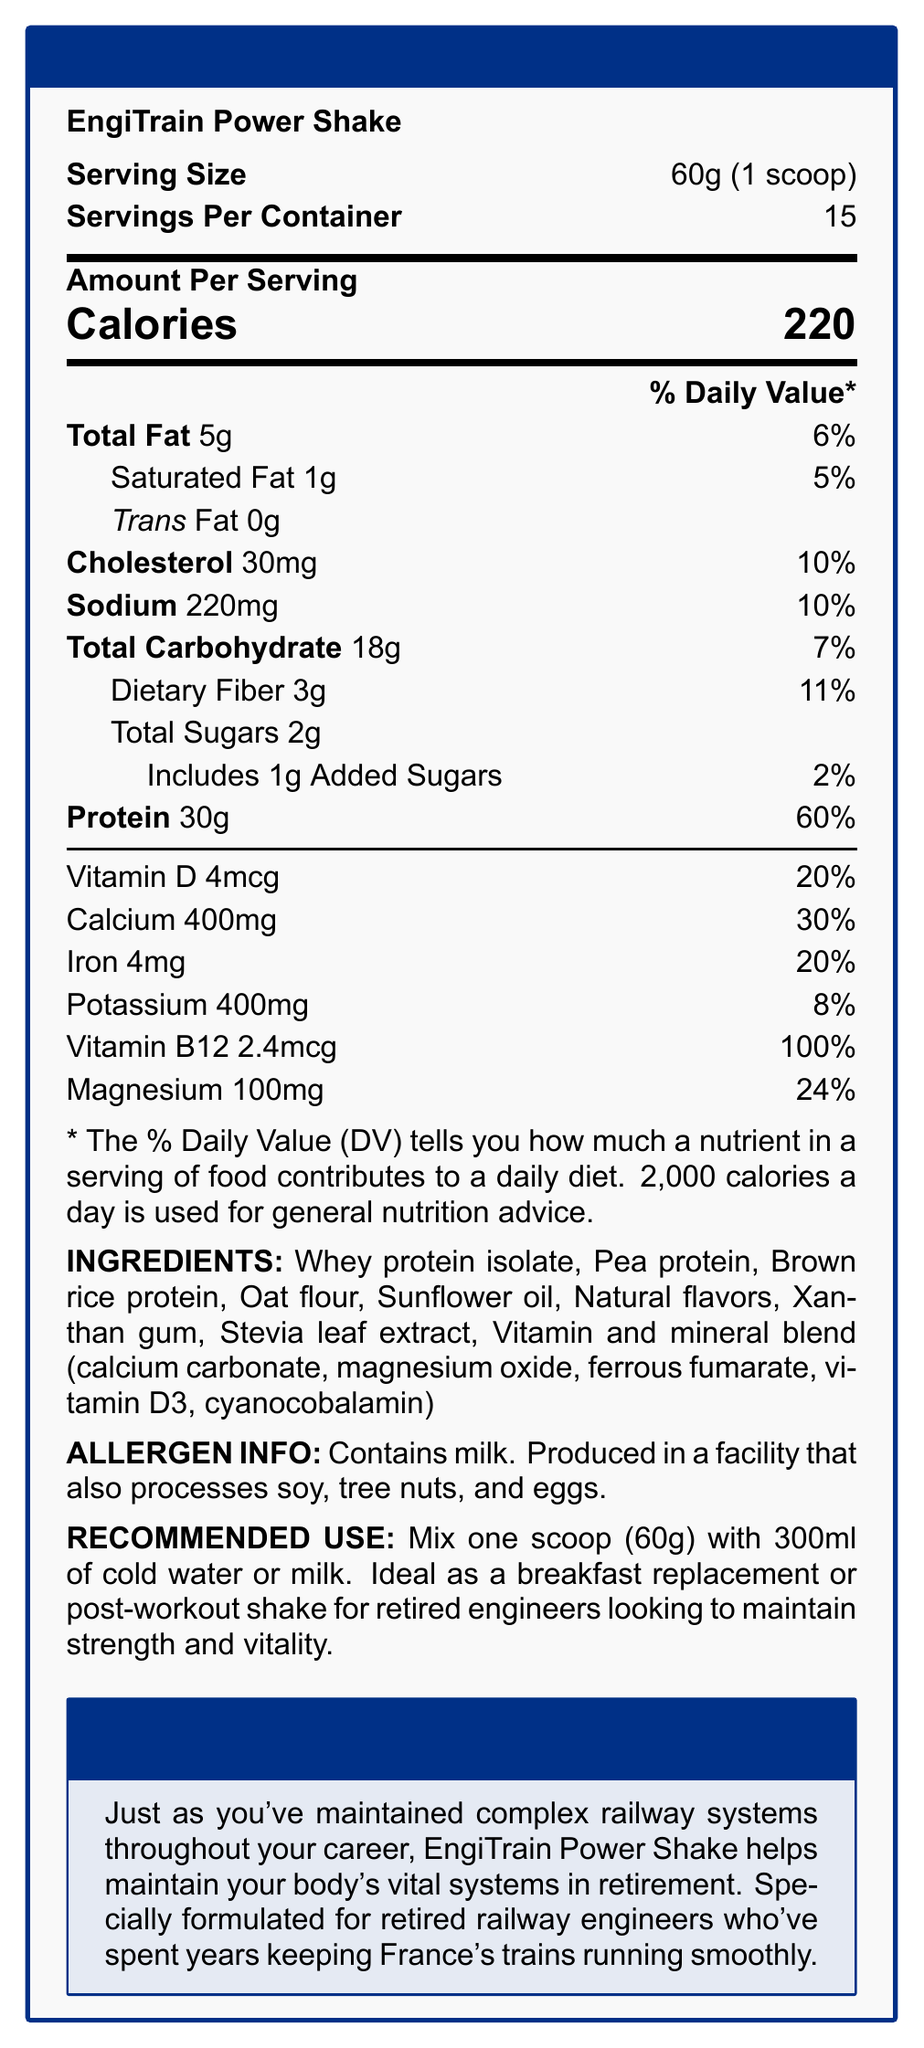what is the serving size of EngiTrain Power Shake? The document specifies the serving size as "60g (1 scoop)".
Answer: 60g (1 scoop) how many servings are there per container of EngiTrain Power Shake? The document states "Servings Per Container" as 15.
Answer: 15 what are the total calories per serving in the EngiTrain Power Shake? The document shows "Calories" with a value of 220.
Answer: 220 how much protein is there per serving and its percent daily value? The document lists "Protein" as 30g per serving and its daily value as 60%.
Answer: 30g, 60% what are the special features of EngiTrain Power Shake? The document lists these features under "specialFeatures".
Answer: High in protein for muscle maintenance, Added calcium and vitamin D for bone health, Iron to support cognitive function, B12 for energy metabolism, Low in sugar to maintain healthy blood glucose levels which ingredient in the EngiTrain Power Shake is associated with "cognitive function support"? A. Vitamin D B. Iron C. Vitamin B12 D. Magnesium One of the special features mentions "Iron to support cognitive function".
Answer: B. Iron how much calcium is there in one serving of EngiTrain Power Shake? The document states "Calcium" content as 400mg.
Answer: 400mg does the EngiTrain Power Shake contain any allergens? The document states that it contains milk and is produced in a facility that processes soy, tree nuts, and eggs.
Answer: Yes which of the following is a recommended use for EngiTrain Power Shake? A. Mix with hot water B. Use as a breakfast replacement C. Mix with juice The document mentions "Ideal as a breakfast replacement or post-workout shake".
Answer: B. Use as a breakfast replacement summarize the entire document in a few sentences. The document provides detailed nutrition facts, ingredients, allergen information, recommended use, and special features of the EngiTrain Power Shake, alongside emphasizing its benefits for retired railway engineers.
Answer: EngiTrain Power Shake is a high-protein meal replacement shake designed for retired railway engineers. Each serving is 60g and contains 220 calories. It is rich in protein, calcium, and essential vitamins and minerals. The product features include benefits for muscle maintenance, bone health, cognitive function, and energy metabolism, with low sugar content. It also contains milk and is produced in a facility processing other allergens. The shake is especially helpful for maintaining strength and vitality in retirement. is the EngiTrain Power Shake ideal for maintaining healthy blood glucose levels? One of the special features listed in the document mentions "Low in sugar to maintain healthy blood glucose levels".
Answer: Yes how much dietary fiber is there per serving? The document states "Dietary Fiber" content as 3g per serving.
Answer: 3g what is the daily value percentage for magnesium in EngiTrain Power Shake? The document lists the daily value for "Magnesium" as 24%.
Answer: 24% what is the flavor of the EngiTrain Power Shake? The document mentions "Natural flavors" but does not specify the exact flavor.
Answer: Not enough information how much iron is there per serving? A. 2mg B. 4mg C. 6mg D. 8mg The document states "Iron" content as 4mg per serving.
Answer: B. 4mg what is the primary source of protein in the EngiTrain Power Shake? The first ingredient listed is "Whey protein isolate", indicating it as the primary source.
Answer: Whey protein isolate 